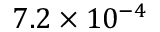Convert formula to latex. <formula><loc_0><loc_0><loc_500><loc_500>7 . 2 \times 1 0 ^ { - 4 }</formula> 